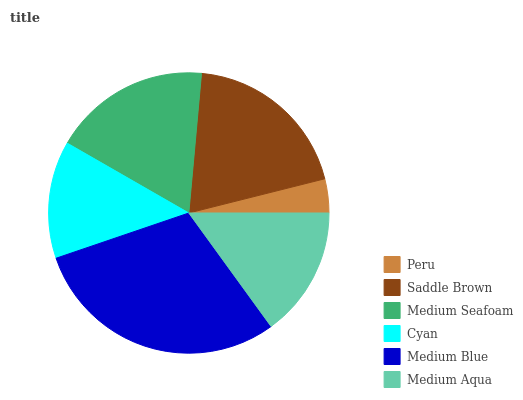Is Peru the minimum?
Answer yes or no. Yes. Is Medium Blue the maximum?
Answer yes or no. Yes. Is Saddle Brown the minimum?
Answer yes or no. No. Is Saddle Brown the maximum?
Answer yes or no. No. Is Saddle Brown greater than Peru?
Answer yes or no. Yes. Is Peru less than Saddle Brown?
Answer yes or no. Yes. Is Peru greater than Saddle Brown?
Answer yes or no. No. Is Saddle Brown less than Peru?
Answer yes or no. No. Is Medium Seafoam the high median?
Answer yes or no. Yes. Is Medium Aqua the low median?
Answer yes or no. Yes. Is Medium Aqua the high median?
Answer yes or no. No. Is Peru the low median?
Answer yes or no. No. 